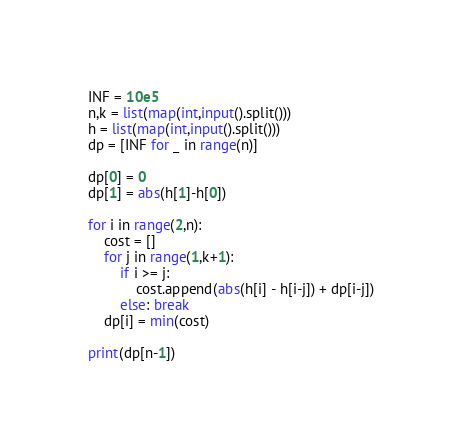<code> <loc_0><loc_0><loc_500><loc_500><_Python_>
INF = 10e5
n,k = list(map(int,input().split()))
h = list(map(int,input().split()))
dp = [INF for _ in range(n)]

dp[0] = 0
dp[1] = abs(h[1]-h[0])

for i in range(2,n):
    cost = []
    for j in range(1,k+1):
        if i >= j:
            cost.append(abs(h[i] - h[i-j]) + dp[i-j])
        else: break
    dp[i] = min(cost)

print(dp[n-1])
</code> 